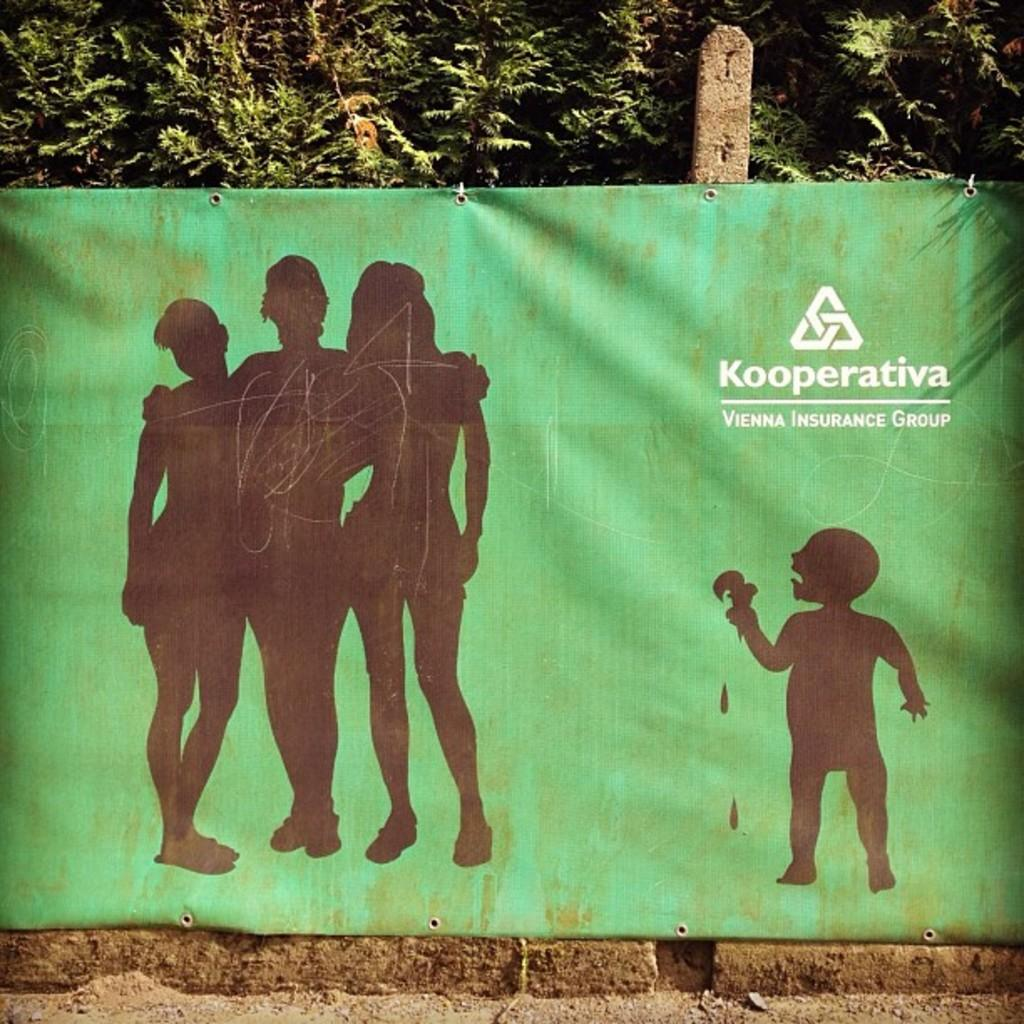What color is the banner in the image? The banner in the image is green. What is happening near the banner? There are people standing near the banner. What can be read on the banner? There is text written on the banner. What can be seen in the distance in the image? There are trees visible in the background of the image. Can you see a suit hanging on the tree in the image? There is no suit hanging on a tree in the image. Is there a snail crawling on the banner in the image? There is no snail present in the image. 